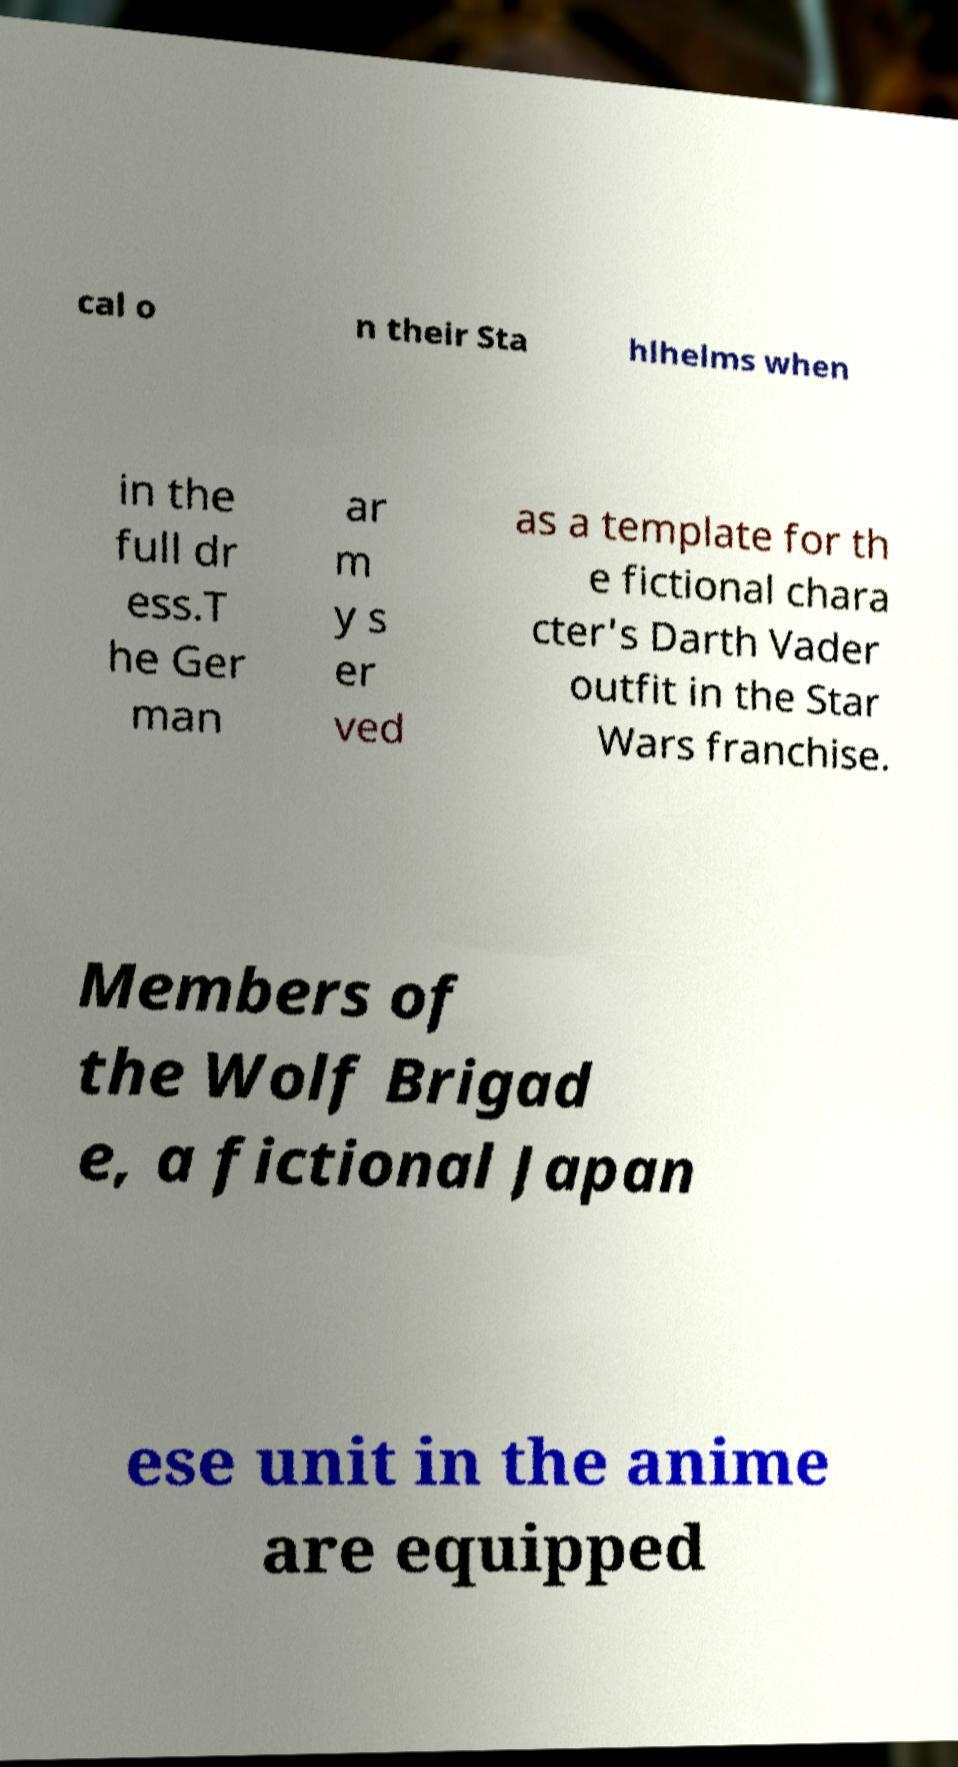Can you accurately transcribe the text from the provided image for me? cal o n their Sta hlhelms when in the full dr ess.T he Ger man ar m y s er ved as a template for th e fictional chara cter's Darth Vader outfit in the Star Wars franchise. Members of the Wolf Brigad e, a fictional Japan ese unit in the anime are equipped 